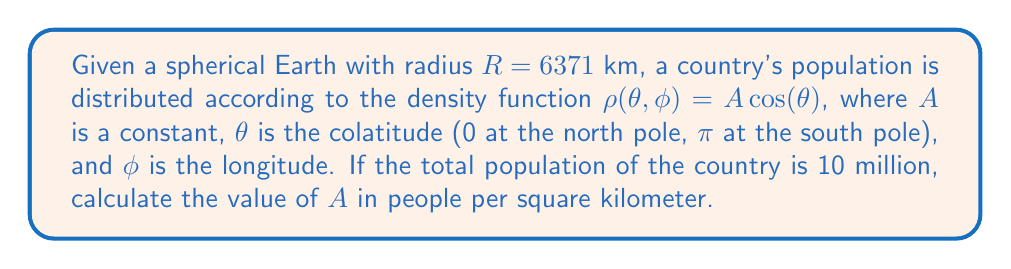Teach me how to tackle this problem. To solve this problem, we'll follow these steps:

1) The total population is the integral of the density function over the surface area of the sphere. In spherical coordinates, this is given by:

   $$P = \int_0^{2\pi} \int_0^{\pi} \rho(\theta, \phi) R^2 \sin(\theta) d\theta d\phi$$

2) Substituting our density function:

   $$10^7 = \int_0^{2\pi} \int_0^{\pi} A \cos(\theta) R^2 \sin(\theta) d\theta d\phi$$

3) The constant terms can be moved outside the integral:

   $$10^7 = A R^2 \int_0^{2\pi} \int_0^{\pi} \cos(\theta) \sin(\theta) d\theta d\phi$$

4) Evaluate the inner integral:

   $$\int_0^{\pi} \cos(\theta) \sin(\theta) d\theta = [-\frac{1}{2}\cos^2(\theta)]_0^{\pi} = 1$$

5) Now our equation becomes:

   $$10^7 = A R^2 \int_0^{2\pi} 1 d\phi = 2\pi A R^2$$

6) Solve for A:

   $$A = \frac{10^7}{2\pi R^2}$$

7) Substitute the value of R:

   $$A = \frac{10^7}{2\pi (6371000)^2} \approx 0.0196 \text{ people/km}^2$$

8) Convert to people per square kilometer:

   $$A \approx 19.6 \text{ people/km}^2$$
Answer: $A \approx 19.6 \text{ people/km}^2$ 